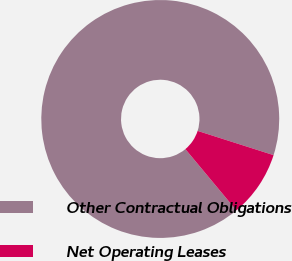Convert chart to OTSL. <chart><loc_0><loc_0><loc_500><loc_500><pie_chart><fcel>Other Contractual Obligations<fcel>Net Operating Leases<nl><fcel>90.97%<fcel>9.03%<nl></chart> 